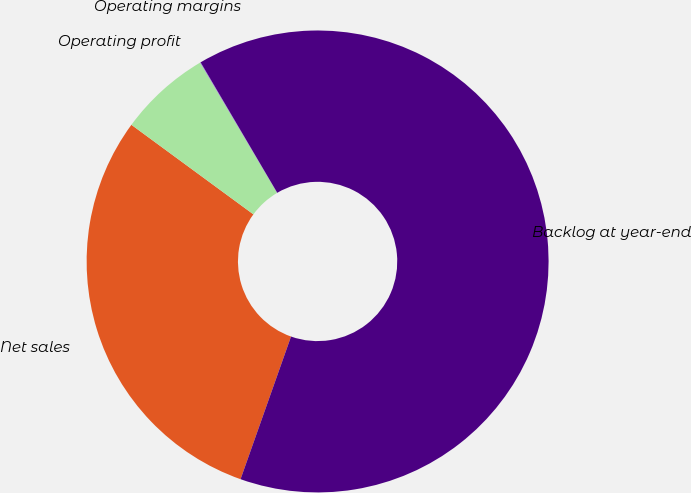Convert chart to OTSL. <chart><loc_0><loc_0><loc_500><loc_500><pie_chart><fcel>Net sales<fcel>Operating profit<fcel>Operating margins<fcel>Backlog at year-end<nl><fcel>29.66%<fcel>6.43%<fcel>0.04%<fcel>63.86%<nl></chart> 